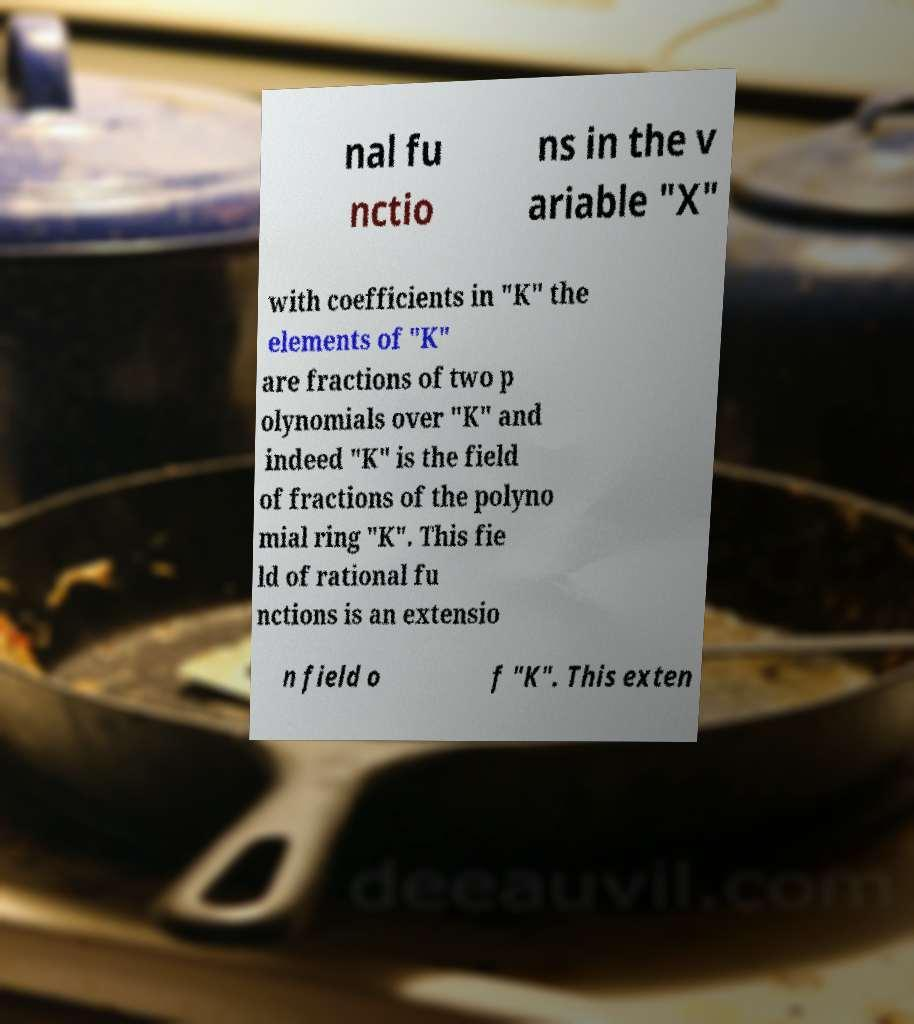I need the written content from this picture converted into text. Can you do that? nal fu nctio ns in the v ariable "X" with coefficients in "K" the elements of "K" are fractions of two p olynomials over "K" and indeed "K" is the field of fractions of the polyno mial ring "K". This fie ld of rational fu nctions is an extensio n field o f "K". This exten 